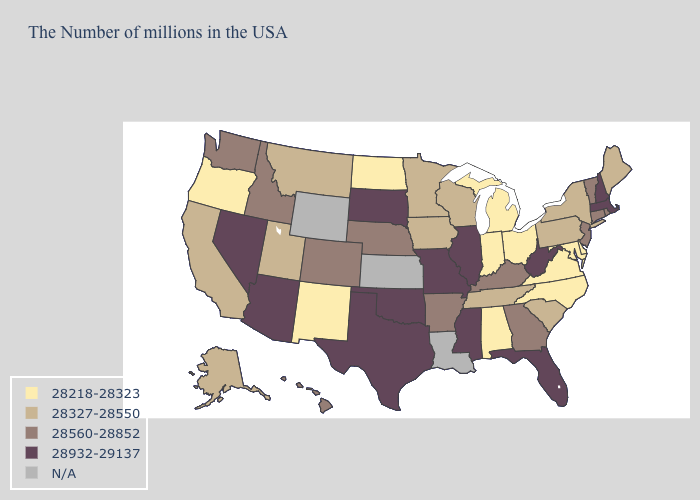Name the states that have a value in the range 28218-28323?
Give a very brief answer. Delaware, Maryland, Virginia, North Carolina, Ohio, Michigan, Indiana, Alabama, North Dakota, New Mexico, Oregon. Name the states that have a value in the range 28327-28550?
Keep it brief. Maine, New York, Pennsylvania, South Carolina, Tennessee, Wisconsin, Minnesota, Iowa, Utah, Montana, California, Alaska. What is the value of Kentucky?
Short answer required. 28560-28852. Which states hav the highest value in the West?
Write a very short answer. Arizona, Nevada. Which states have the lowest value in the USA?
Quick response, please. Delaware, Maryland, Virginia, North Carolina, Ohio, Michigan, Indiana, Alabama, North Dakota, New Mexico, Oregon. What is the value of Louisiana?
Be succinct. N/A. Name the states that have a value in the range N/A?
Keep it brief. Louisiana, Kansas, Wyoming. Does South Carolina have the lowest value in the South?
Keep it brief. No. Does the map have missing data?
Keep it brief. Yes. Name the states that have a value in the range 28560-28852?
Concise answer only. Rhode Island, Vermont, Connecticut, New Jersey, Georgia, Kentucky, Arkansas, Nebraska, Colorado, Idaho, Washington, Hawaii. What is the value of Kansas?
Concise answer only. N/A. What is the value of Nebraska?
Be succinct. 28560-28852. Name the states that have a value in the range 28560-28852?
Keep it brief. Rhode Island, Vermont, Connecticut, New Jersey, Georgia, Kentucky, Arkansas, Nebraska, Colorado, Idaho, Washington, Hawaii. Which states hav the highest value in the South?
Short answer required. West Virginia, Florida, Mississippi, Oklahoma, Texas. Does the map have missing data?
Give a very brief answer. Yes. 